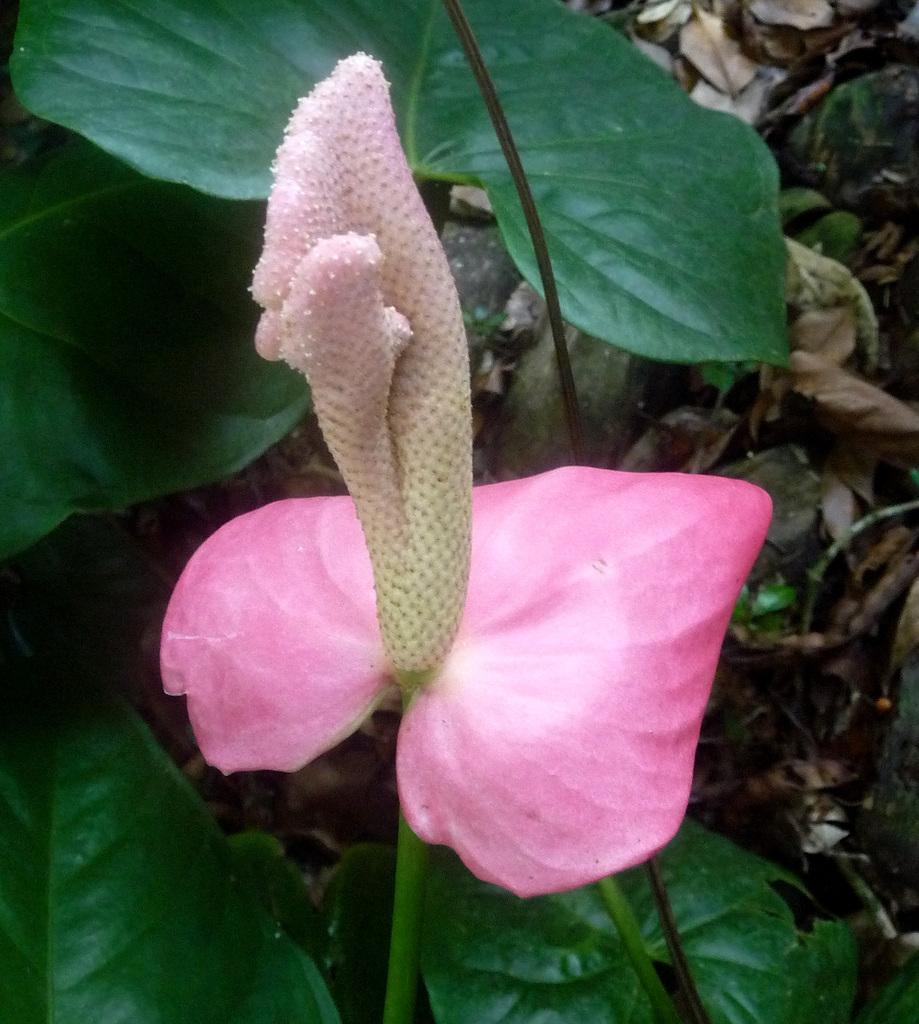In one or two sentences, can you explain what this image depicts? In this picture we can see a pink flower, green leaves and some dried leaves in the background. 